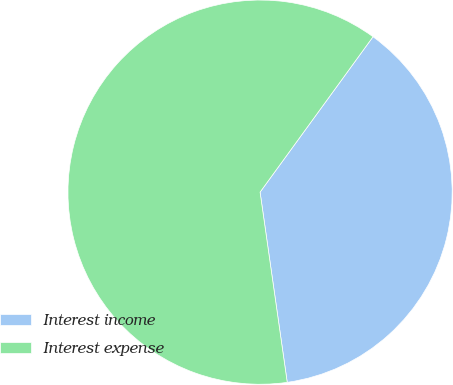Convert chart to OTSL. <chart><loc_0><loc_0><loc_500><loc_500><pie_chart><fcel>Interest income<fcel>Interest expense<nl><fcel>37.74%<fcel>62.26%<nl></chart> 